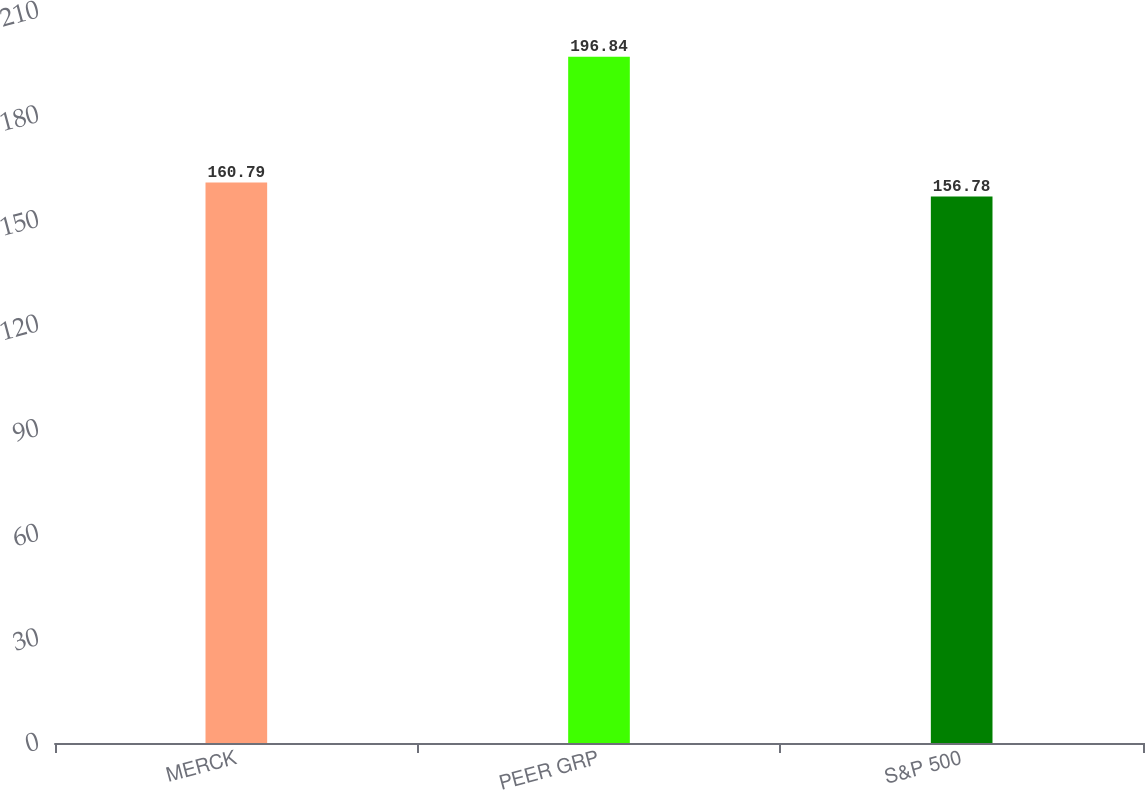Convert chart to OTSL. <chart><loc_0><loc_0><loc_500><loc_500><bar_chart><fcel>MERCK<fcel>PEER GRP<fcel>S&P 500<nl><fcel>160.79<fcel>196.84<fcel>156.78<nl></chart> 